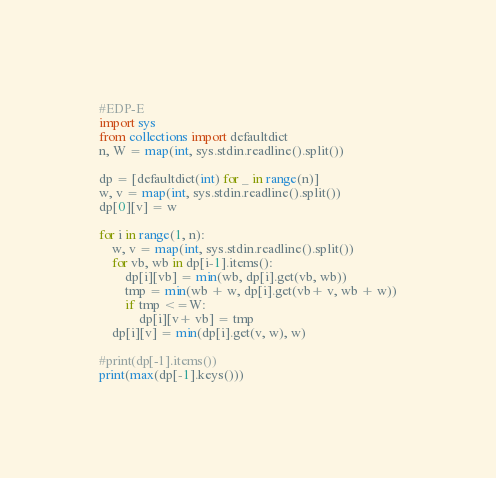<code> <loc_0><loc_0><loc_500><loc_500><_Python_>#EDP-E
import sys
from collections import defaultdict
n, W = map(int, sys.stdin.readline().split())

dp = [defaultdict(int) for _ in range(n)]
w, v = map(int, sys.stdin.readline().split())
dp[0][v] = w

for i in range(1, n):
    w, v = map(int, sys.stdin.readline().split())
    for vb, wb in dp[i-1].items():
        dp[i][vb] = min(wb, dp[i].get(vb, wb))
        tmp = min(wb + w, dp[i].get(vb+ v, wb + w))
        if tmp <=W:
            dp[i][v+ vb] = tmp
    dp[i][v] = min(dp[i].get(v, w), w)

#print(dp[-1].items())
print(max(dp[-1].keys()))
</code> 